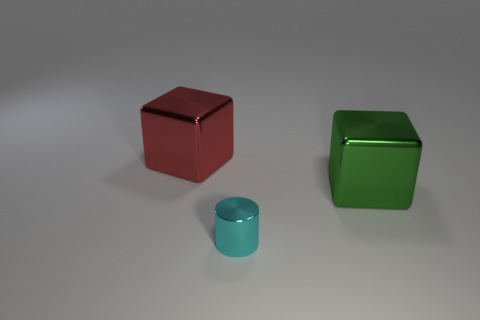Add 1 blue metallic cubes. How many objects exist? 4 Subtract all cylinders. How many objects are left? 2 Subtract 0 brown spheres. How many objects are left? 3 Subtract all green metallic cylinders. Subtract all green blocks. How many objects are left? 2 Add 1 green metallic cubes. How many green metallic cubes are left? 2 Add 2 large yellow metal objects. How many large yellow metal objects exist? 2 